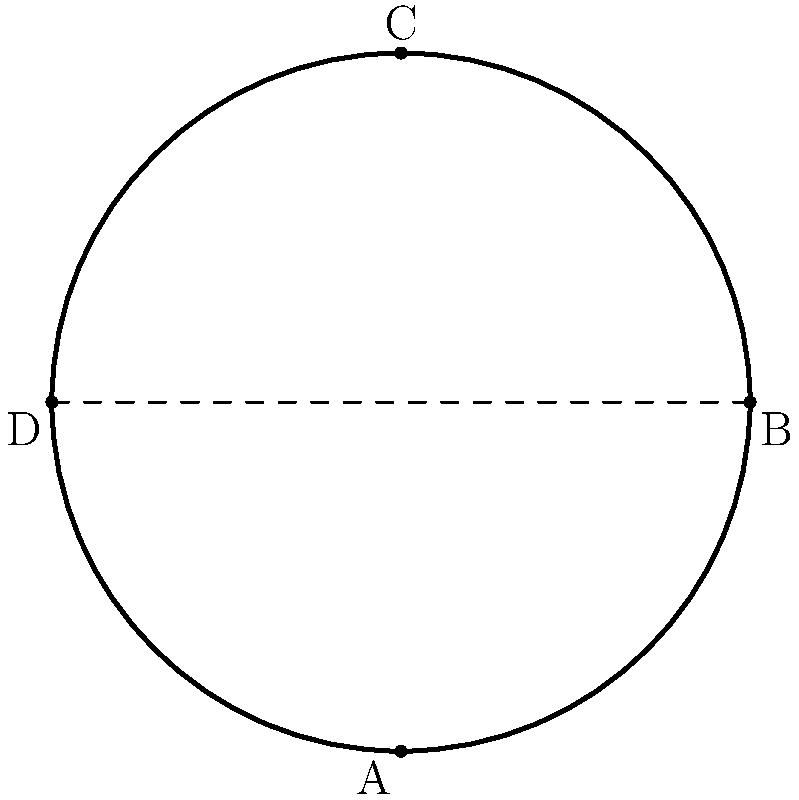The diagram shows a flat, irregular shell pattern. If the pattern is folded along the dashed line, which point will overlap with point C? To solve this problem, we need to visualize the folding process:

1. The dashed line acts as the fold axis.
2. When folded, the upper part of the shell (above the dashed line) will flip over onto the lower part.
3. Point C is the only point above the fold line.
4. To determine which point C will overlap with, we need to find its mirror image across the fold line.
5. Observe that point A is directly below point C, and the distance from A to the fold line is equal to the distance from C to the fold line.
6. Therefore, when folded, point C will overlap with point A.

This visualization exercise requires spatial intelligence to mentally manipulate the 2D shape and imagine its folded form.
Answer: A 